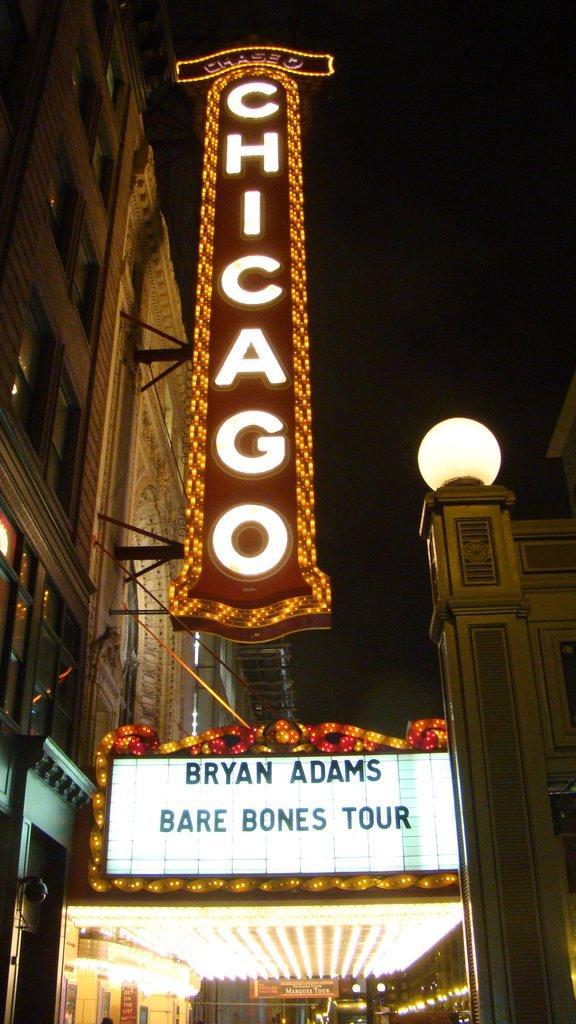Please provide a concise description of this image. In this image we can see a shop and banner. Left side of the image building is there with lights of banner board. Right side of the image one wall is there with light. 